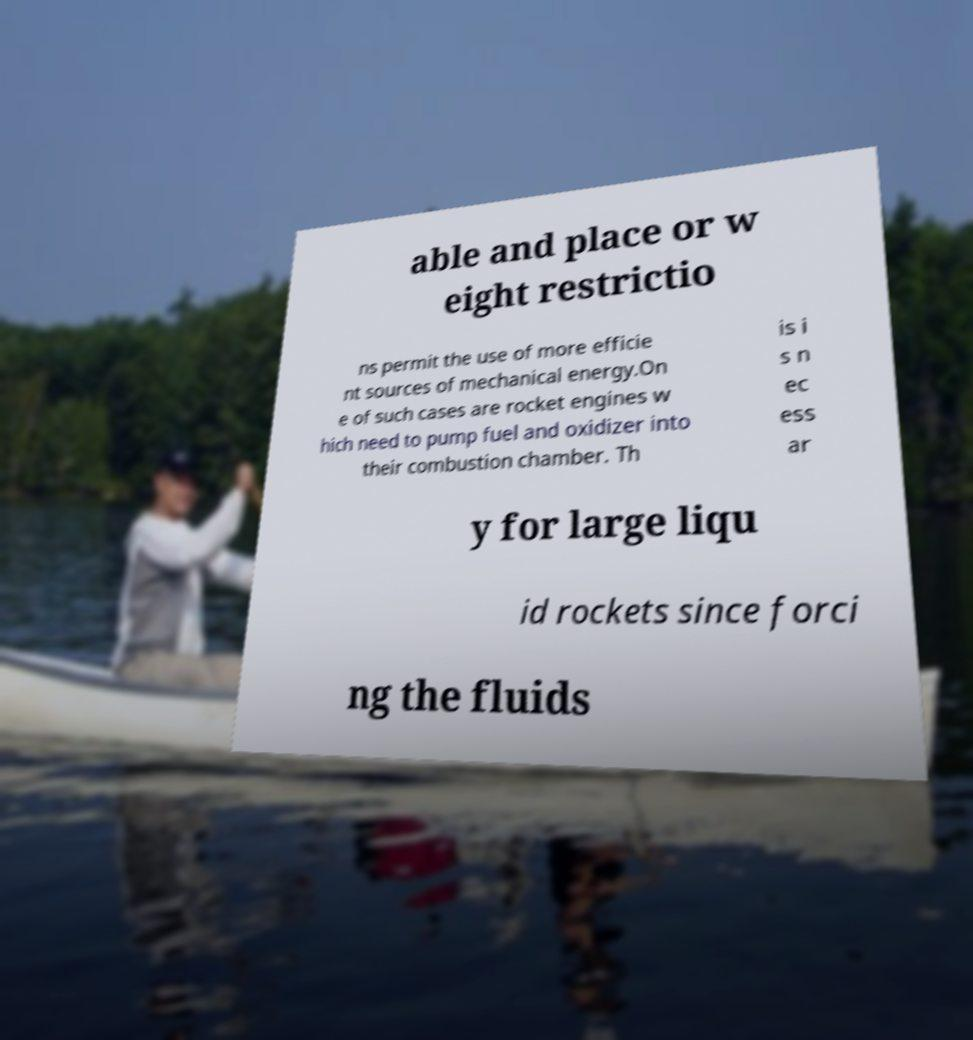There's text embedded in this image that I need extracted. Can you transcribe it verbatim? able and place or w eight restrictio ns permit the use of more efficie nt sources of mechanical energy.On e of such cases are rocket engines w hich need to pump fuel and oxidizer into their combustion chamber. Th is i s n ec ess ar y for large liqu id rockets since forci ng the fluids 